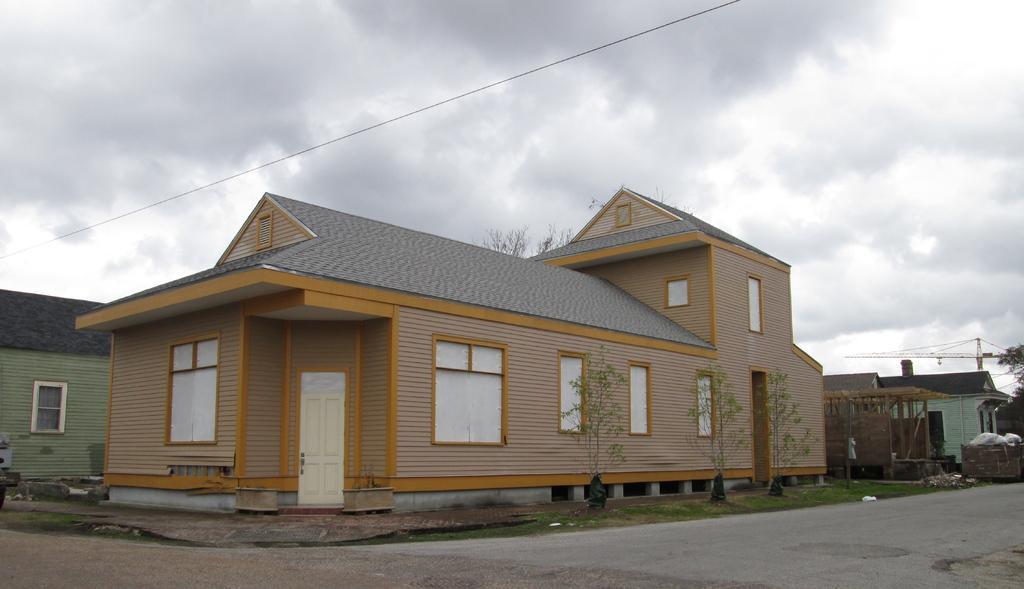Could you give a brief overview of what you see in this image? In this picture we can see road, houses, plants, trees, grass, trash in a garbage bin, crane and wire. In the background of the image we can see the sky. 